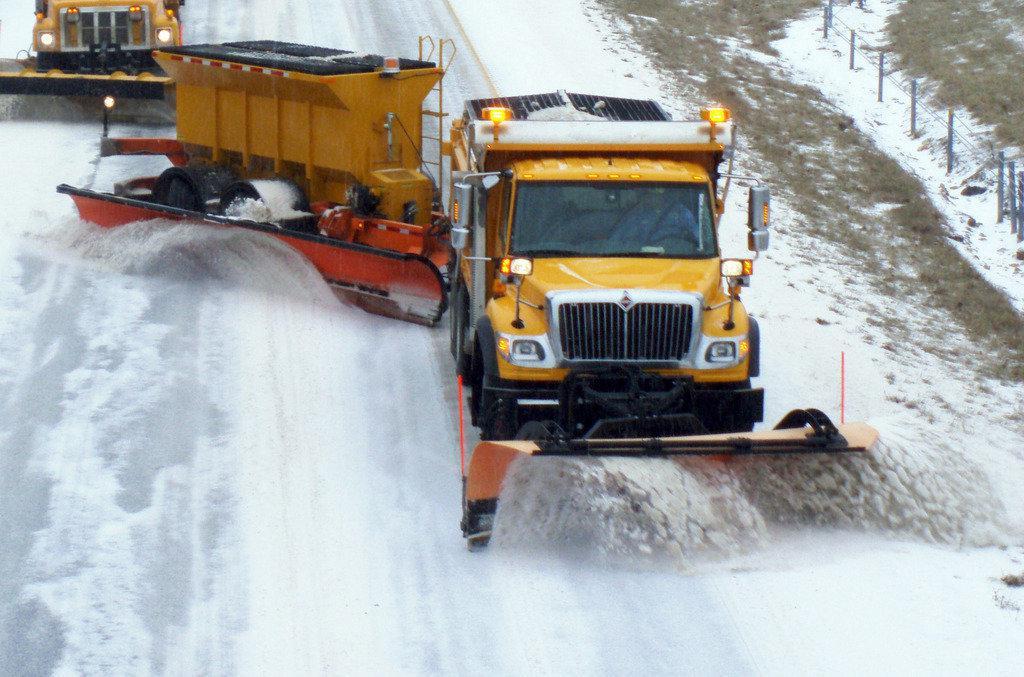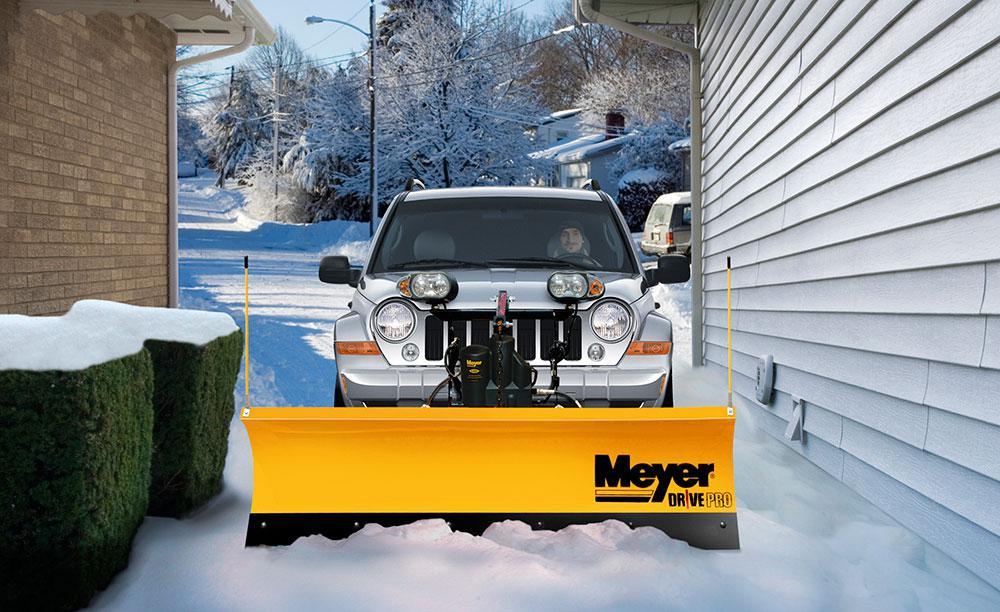The first image is the image on the left, the second image is the image on the right. Analyze the images presented: Is the assertion "An image shows a box-shaped machine with a plow, which has no human driver and no truck pulling it." valid? Answer yes or no. No. 